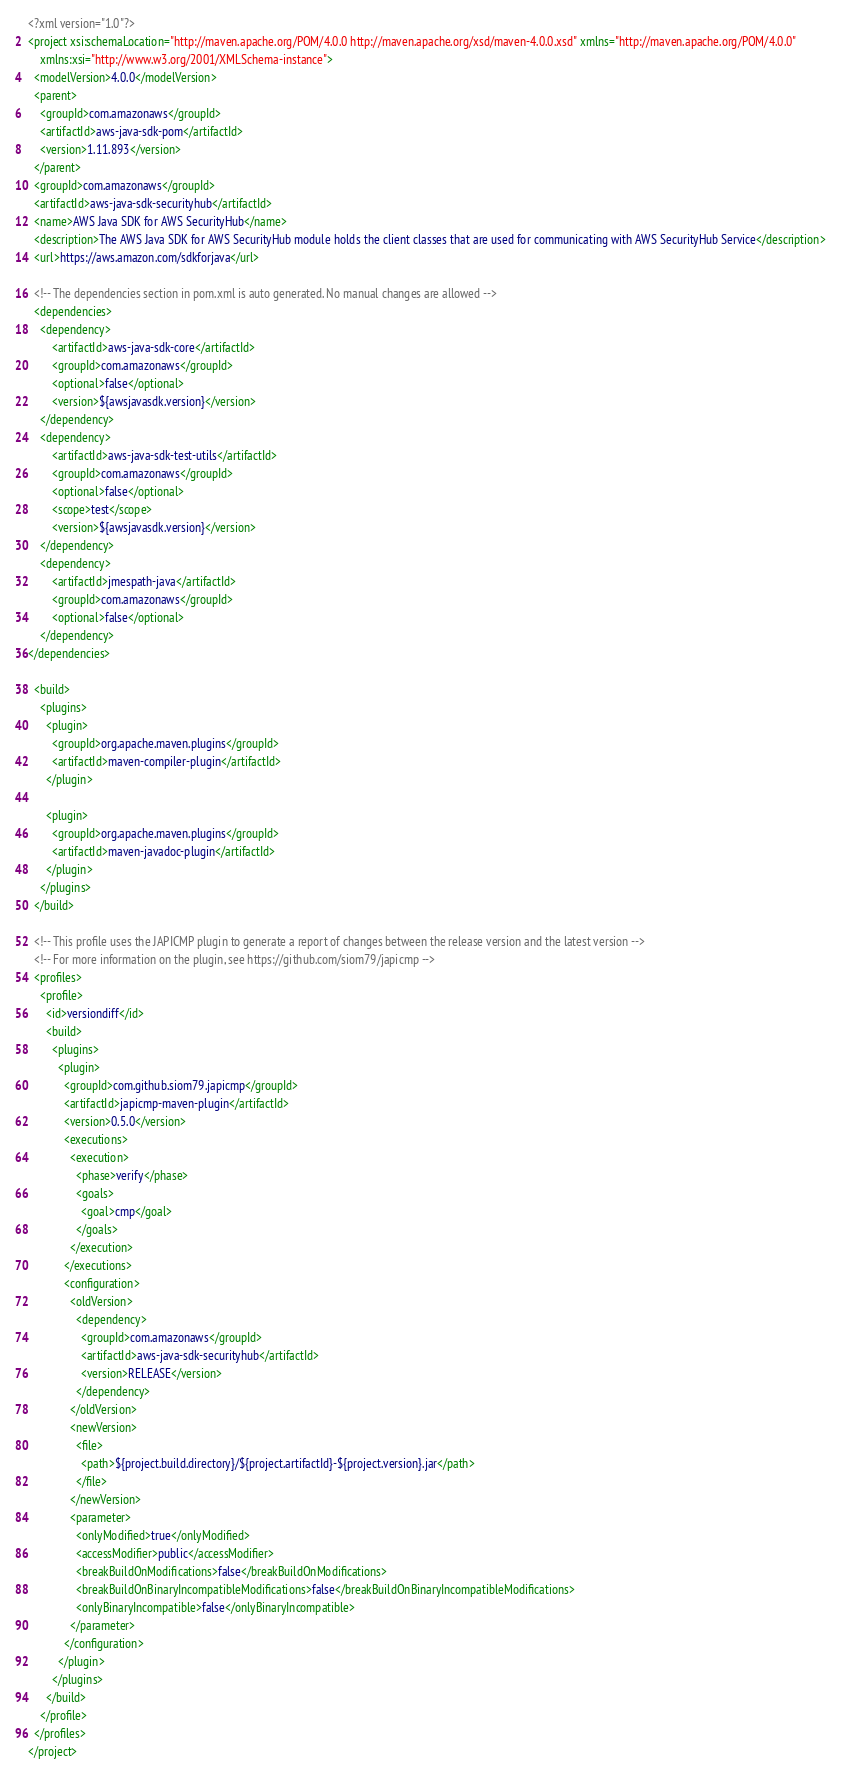Convert code to text. <code><loc_0><loc_0><loc_500><loc_500><_XML_><?xml version="1.0"?>
<project xsi:schemaLocation="http://maven.apache.org/POM/4.0.0 http://maven.apache.org/xsd/maven-4.0.0.xsd" xmlns="http://maven.apache.org/POM/4.0.0"
    xmlns:xsi="http://www.w3.org/2001/XMLSchema-instance">
  <modelVersion>4.0.0</modelVersion>
  <parent>
    <groupId>com.amazonaws</groupId>
    <artifactId>aws-java-sdk-pom</artifactId>
    <version>1.11.893</version>
  </parent>
  <groupId>com.amazonaws</groupId>
  <artifactId>aws-java-sdk-securityhub</artifactId>
  <name>AWS Java SDK for AWS SecurityHub</name>
  <description>The AWS Java SDK for AWS SecurityHub module holds the client classes that are used for communicating with AWS SecurityHub Service</description>
  <url>https://aws.amazon.com/sdkforjava</url>

  <!-- The dependencies section in pom.xml is auto generated. No manual changes are allowed -->
  <dependencies>
    <dependency>
        <artifactId>aws-java-sdk-core</artifactId>
        <groupId>com.amazonaws</groupId>
        <optional>false</optional>
        <version>${awsjavasdk.version}</version>
    </dependency>
    <dependency>
        <artifactId>aws-java-sdk-test-utils</artifactId>
        <groupId>com.amazonaws</groupId>
        <optional>false</optional>
        <scope>test</scope>
        <version>${awsjavasdk.version}</version>
    </dependency>
    <dependency>
        <artifactId>jmespath-java</artifactId>
        <groupId>com.amazonaws</groupId>
        <optional>false</optional>
    </dependency>
</dependencies>

  <build>
    <plugins>
      <plugin>
        <groupId>org.apache.maven.plugins</groupId>
        <artifactId>maven-compiler-plugin</artifactId>
      </plugin>

      <plugin>
        <groupId>org.apache.maven.plugins</groupId>
        <artifactId>maven-javadoc-plugin</artifactId>
      </plugin>
    </plugins>
  </build>

  <!-- This profile uses the JAPICMP plugin to generate a report of changes between the release version and the latest version -->
  <!-- For more information on the plugin, see https://github.com/siom79/japicmp -->
  <profiles>
    <profile>
      <id>versiondiff</id>
      <build>
        <plugins>
          <plugin>
            <groupId>com.github.siom79.japicmp</groupId>
            <artifactId>japicmp-maven-plugin</artifactId>
            <version>0.5.0</version>
            <executions>
              <execution>
                <phase>verify</phase>
                <goals>
                  <goal>cmp</goal>
                </goals>
              </execution>
            </executions>
            <configuration>
              <oldVersion>
                <dependency>
                  <groupId>com.amazonaws</groupId>
                  <artifactId>aws-java-sdk-securityhub</artifactId>
                  <version>RELEASE</version>
                </dependency>
              </oldVersion>
              <newVersion>
                <file>
                  <path>${project.build.directory}/${project.artifactId}-${project.version}.jar</path>
                </file>
              </newVersion>
              <parameter>
                <onlyModified>true</onlyModified>
                <accessModifier>public</accessModifier>
                <breakBuildOnModifications>false</breakBuildOnModifications>
                <breakBuildOnBinaryIncompatibleModifications>false</breakBuildOnBinaryIncompatibleModifications>
                <onlyBinaryIncompatible>false</onlyBinaryIncompatible>
              </parameter>
            </configuration>
          </plugin>
        </plugins>
      </build>
    </profile>
  </profiles>
</project>
</code> 